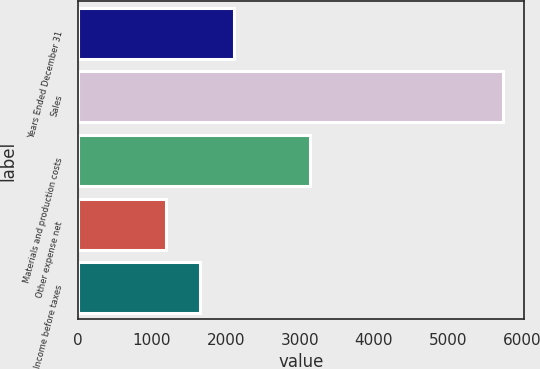Convert chart to OTSL. <chart><loc_0><loc_0><loc_500><loc_500><bar_chart><fcel>Years Ended December 31<fcel>Sales<fcel>Materials and production costs<fcel>Other expense net<fcel>Income before taxes<nl><fcel>2104<fcel>5744<fcel>3137<fcel>1194<fcel>1649<nl></chart> 